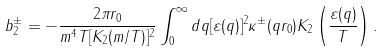<formula> <loc_0><loc_0><loc_500><loc_500>b ^ { \pm } _ { 2 } = - \frac { 2 \pi r _ { 0 } } { m ^ { 4 } T [ K _ { 2 } ( m / T ) ] ^ { 2 } } \int _ { 0 } ^ { \infty } d q [ \varepsilon ( q ) ] ^ { 2 } \kappa ^ { \pm } ( q r _ { 0 } ) K _ { 2 } \left ( \frac { \varepsilon ( q ) } { T } \right ) .</formula> 